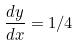Convert formula to latex. <formula><loc_0><loc_0><loc_500><loc_500>\frac { d y } { d x } = 1 / 4</formula> 